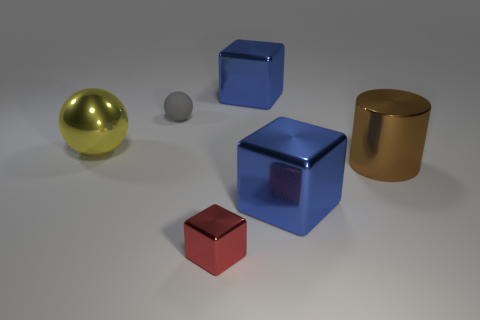Is there a object that is in front of the big metal block behind the rubber sphere?
Make the answer very short. Yes. There is a big thing behind the large metallic object that is on the left side of the tiny red thing; what number of red shiny things are behind it?
Provide a succinct answer. 0. Are there fewer small yellow rubber blocks than big shiny objects?
Your answer should be compact. Yes. There is a large brown metal thing that is behind the red block; does it have the same shape as the large blue metal thing in front of the tiny matte ball?
Your answer should be very brief. No. What color is the big cylinder?
Make the answer very short. Brown. How many metal things are big things or small cylinders?
Provide a succinct answer. 4. What is the color of the metallic thing that is the same shape as the matte object?
Your answer should be compact. Yellow. Is there a large blue metallic block?
Offer a terse response. Yes. Does the yellow object that is left of the brown cylinder have the same material as the large blue block that is in front of the brown thing?
Provide a succinct answer. Yes. How many objects are blue shiny things behind the rubber sphere or blocks that are in front of the big metallic ball?
Give a very brief answer. 3. 